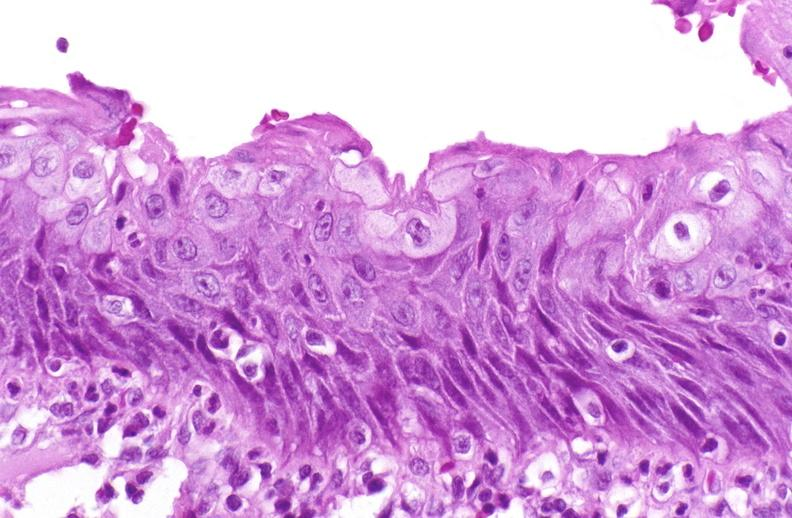where is this?
Answer the question using a single word or phrase. Urinary 